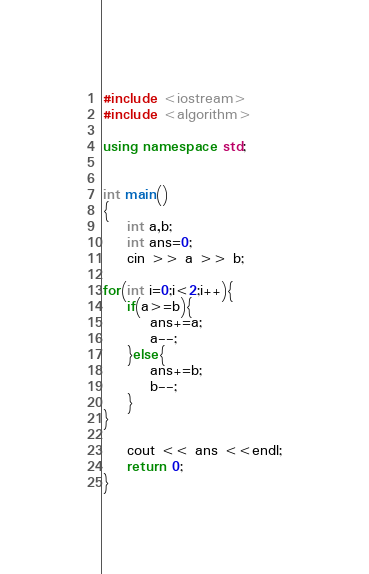<code> <loc_0><loc_0><loc_500><loc_500><_C++_>#include <iostream>
#include <algorithm>

using namespace std;


int main()
{
    int a,b;
    int ans=0;
    cin >> a >> b;

for(int i=0;i<2;i++){
    if(a>=b){
        ans+=a;
        a--;
    }else{
        ans+=b;
        b--;
    }
}

    cout << ans <<endl;
	return 0;
}</code> 